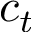Convert formula to latex. <formula><loc_0><loc_0><loc_500><loc_500>c _ { t }</formula> 